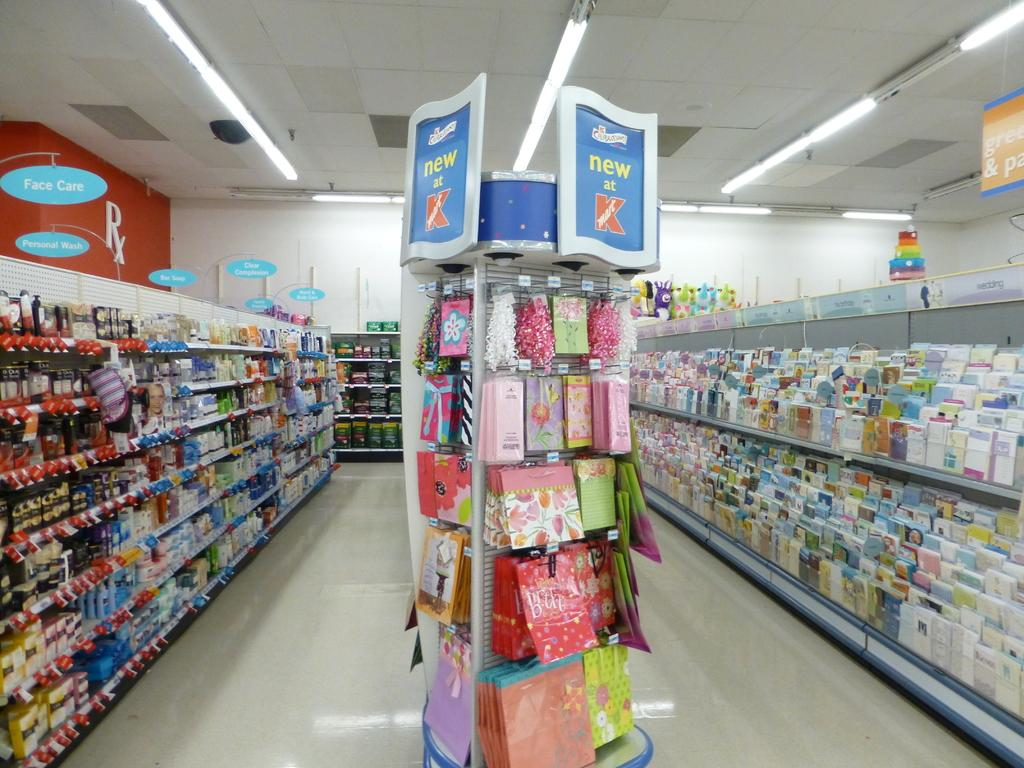<image>
Share a concise interpretation of the image provided. Postcards, gift bags and signs that say face care, personal wash, etc are seen in this store. 